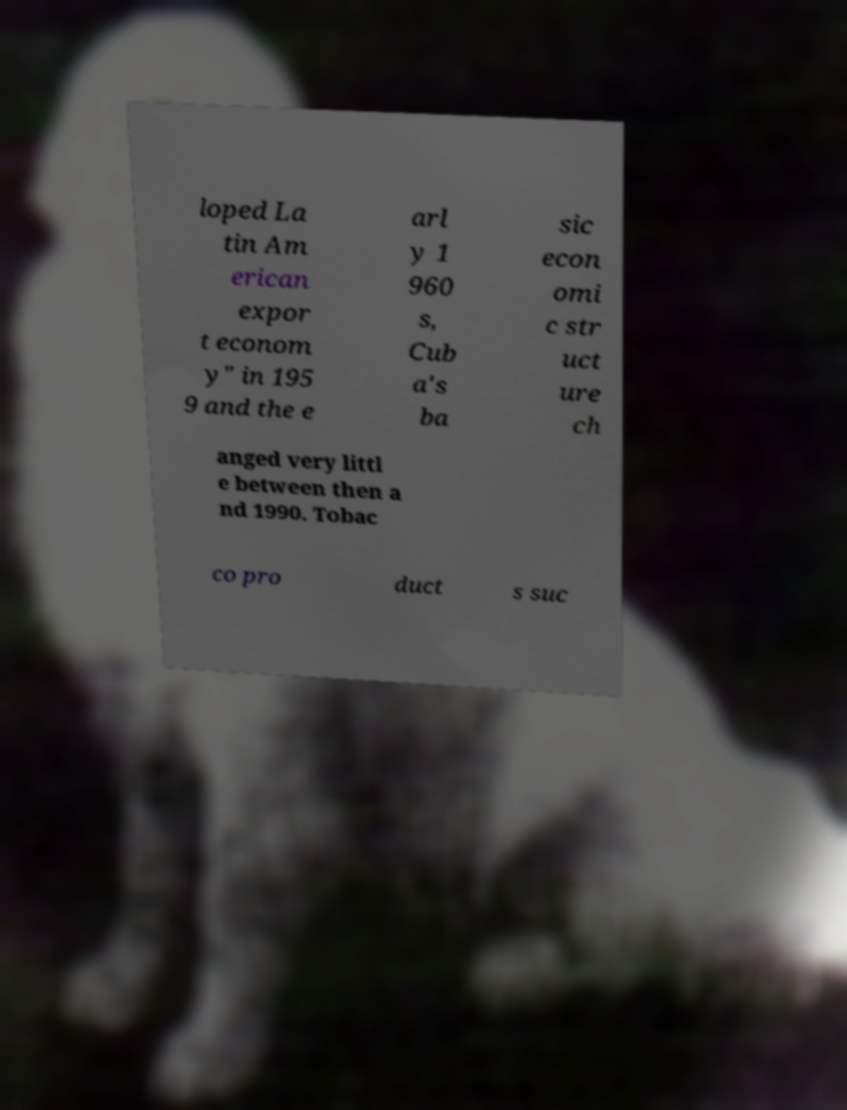There's text embedded in this image that I need extracted. Can you transcribe it verbatim? loped La tin Am erican expor t econom y" in 195 9 and the e arl y 1 960 s, Cub a's ba sic econ omi c str uct ure ch anged very littl e between then a nd 1990. Tobac co pro duct s suc 